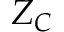<formula> <loc_0><loc_0><loc_500><loc_500>Z _ { C }</formula> 